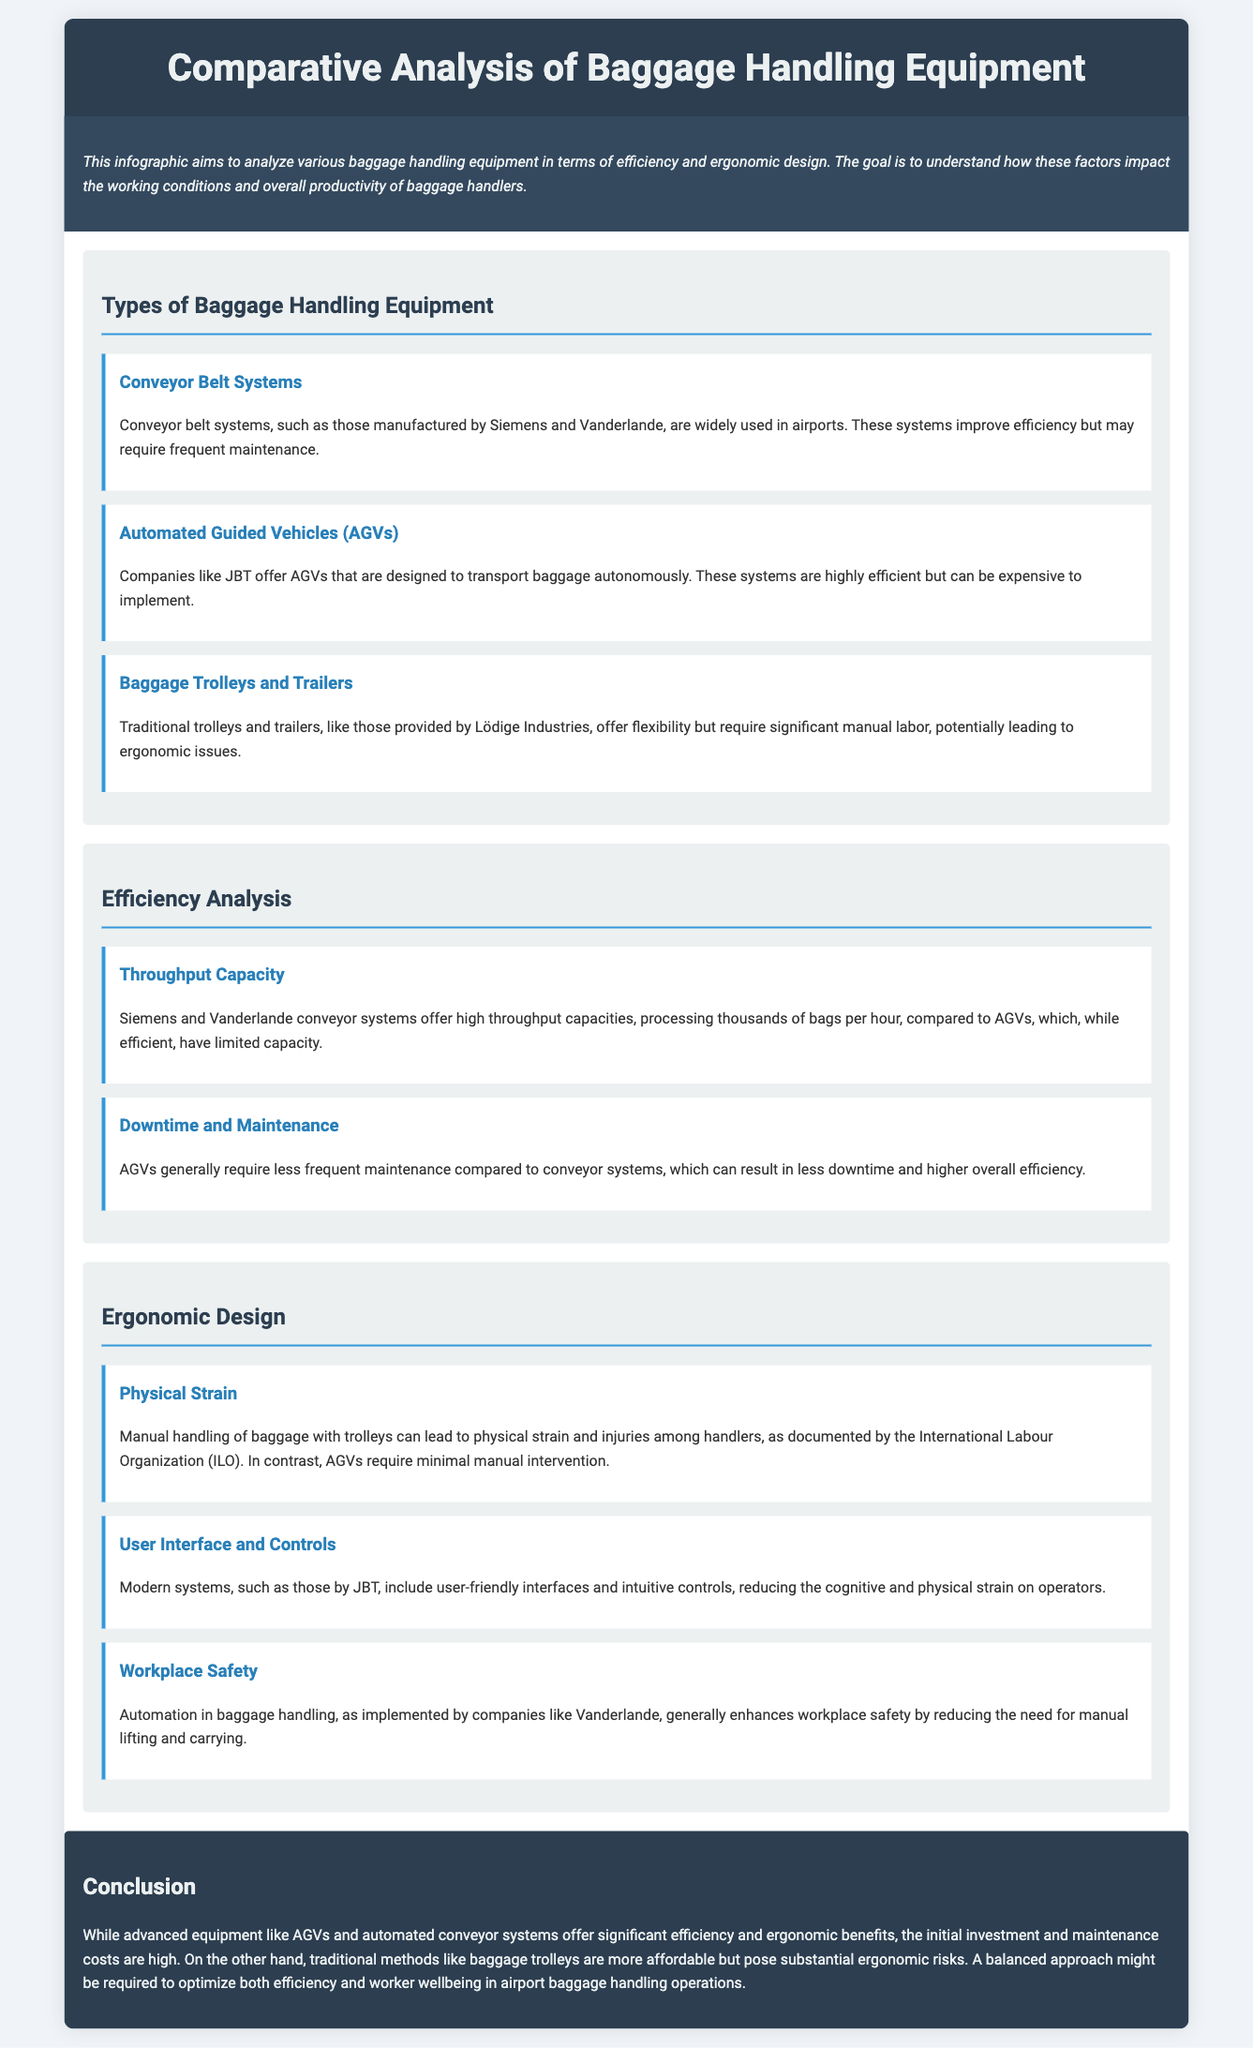What are the three types of baggage handling equipment mentioned? The types of baggage handling equipment are Conveyor Belt Systems, Automated Guided Vehicles (AGVs), and Baggage Trolleys and Trailers.
Answer: Conveyor Belt Systems, Automated Guided Vehicles (AGVs), Baggage Trolleys and Trailers Which companies manufacture Conveyor Belt Systems? Siemens and Vanderlande are the companies mentioned that manufacture conveyor belt systems.
Answer: Siemens and Vanderlande What is a potential ergonomic issue with traditional baggage trolleys? Traditional trolleys require significant manual labor, which can lead to ergonomic issues for baggage handlers.
Answer: Ergonomic issues What are the benefits of AGVs regarding maintenance? AGVs generally require less frequent maintenance compared to conveyor systems.
Answer: Less frequent maintenance What is the impact of automation on workplace safety? Automation generally enhances workplace safety by reducing the need for manual lifting and carrying.
Answer: Enhances workplace safety What is the main advantage of conveyor systems in terms of throughput capacity? Conveyor systems can process thousands of bags per hour, offering high throughput capacities.
Answer: High throughput capacities Which ergonomic factor is minimized by using AGVs? AGVs require minimal manual intervention, reducing physical strain on handlers.
Answer: Physical strain What conclusion is drawn regarding the balance in baggage handling equipment? A balanced approach is required to optimize both efficiency and worker wellbeing.
Answer: Balanced approach 